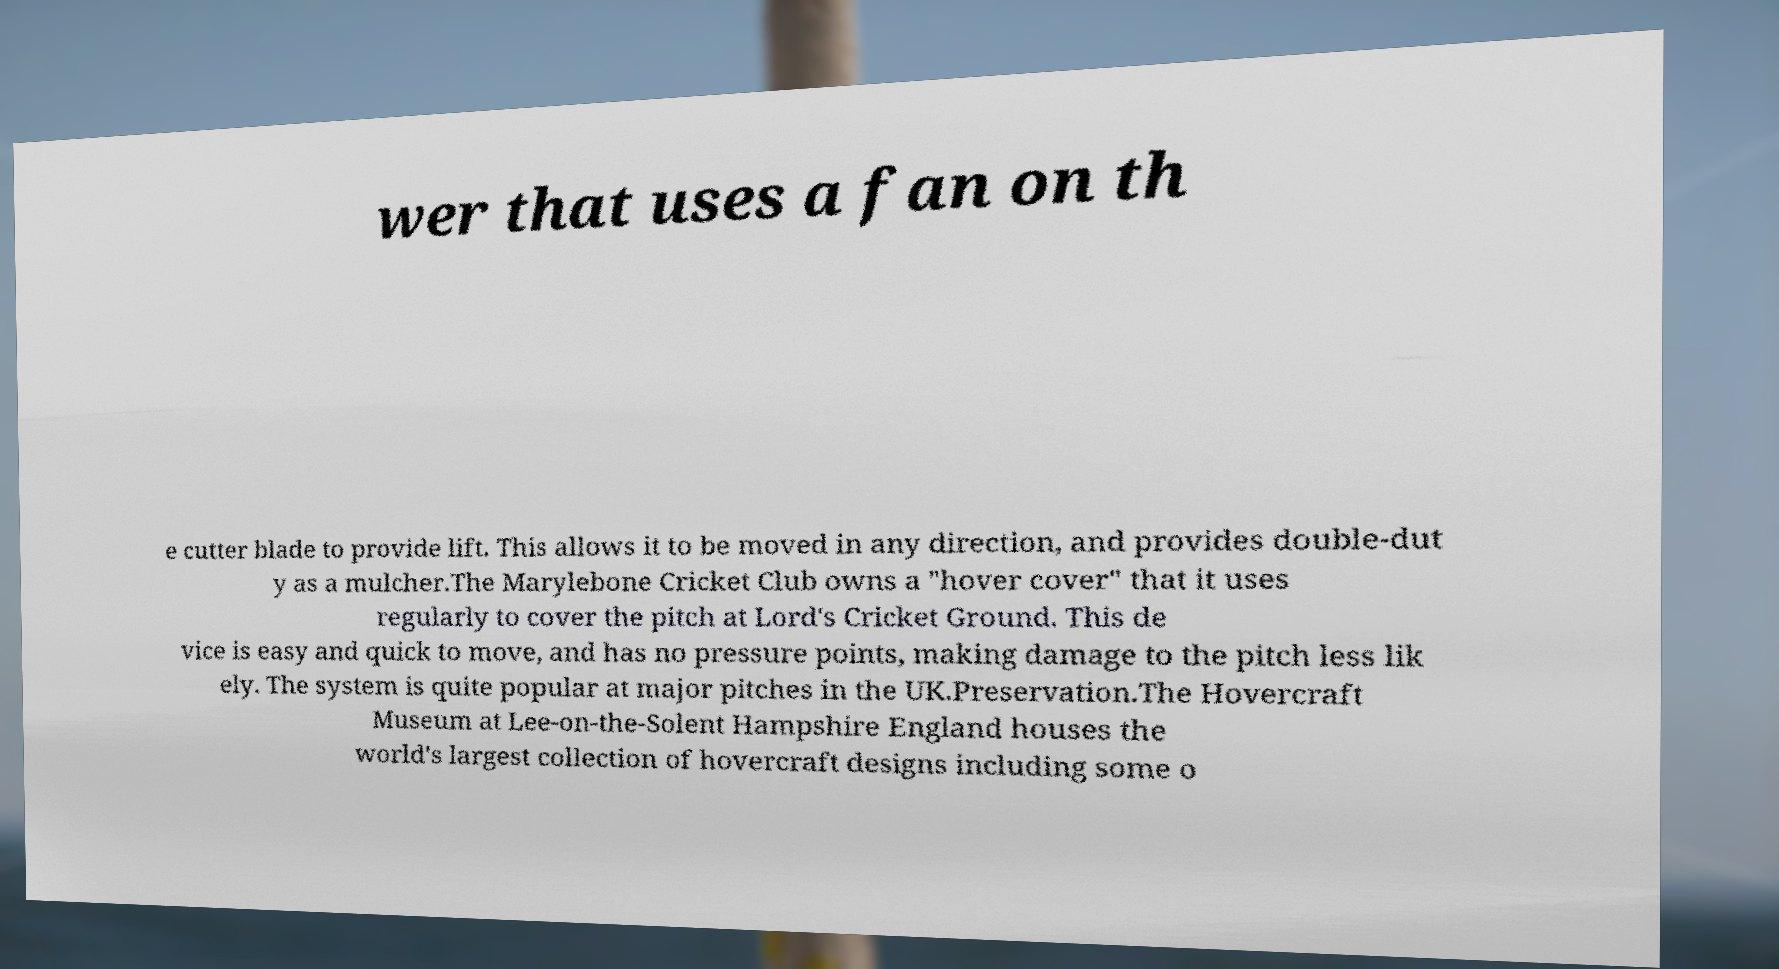Could you extract and type out the text from this image? wer that uses a fan on th e cutter blade to provide lift. This allows it to be moved in any direction, and provides double-dut y as a mulcher.The Marylebone Cricket Club owns a "hover cover" that it uses regularly to cover the pitch at Lord's Cricket Ground. This de vice is easy and quick to move, and has no pressure points, making damage to the pitch less lik ely. The system is quite popular at major pitches in the UK.Preservation.The Hovercraft Museum at Lee-on-the-Solent Hampshire England houses the world's largest collection of hovercraft designs including some o 